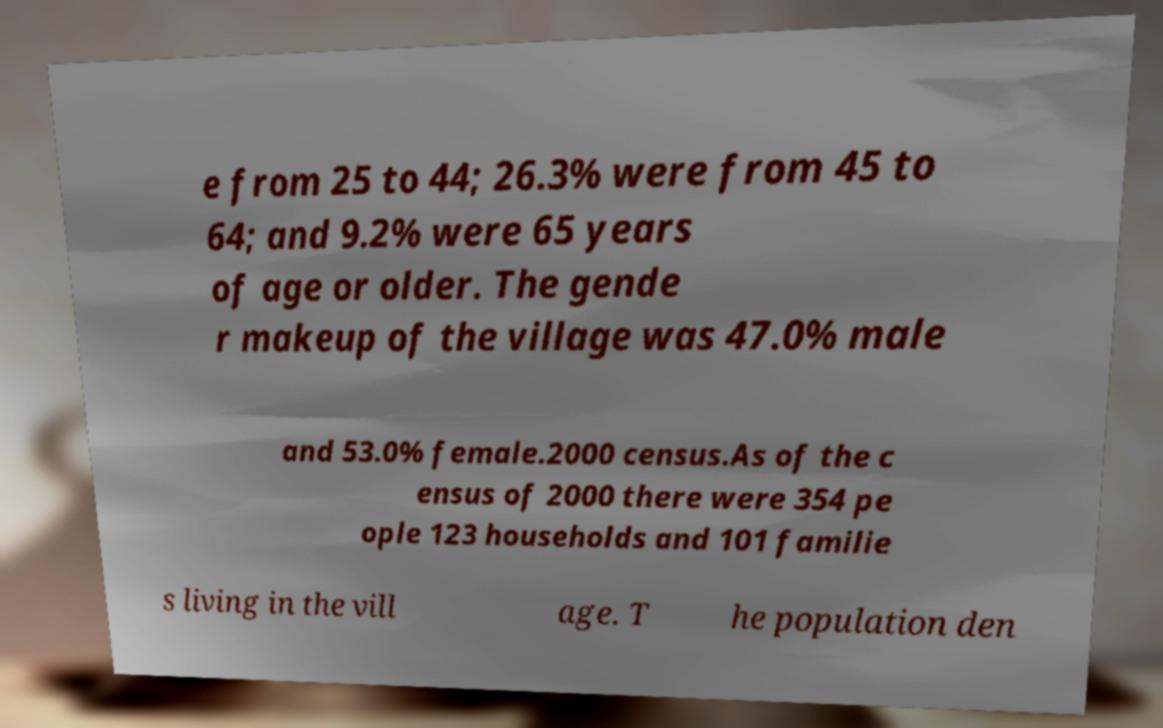Please identify and transcribe the text found in this image. e from 25 to 44; 26.3% were from 45 to 64; and 9.2% were 65 years of age or older. The gende r makeup of the village was 47.0% male and 53.0% female.2000 census.As of the c ensus of 2000 there were 354 pe ople 123 households and 101 familie s living in the vill age. T he population den 